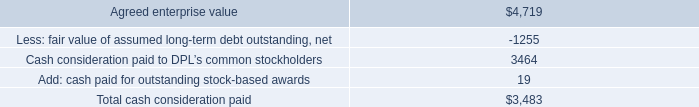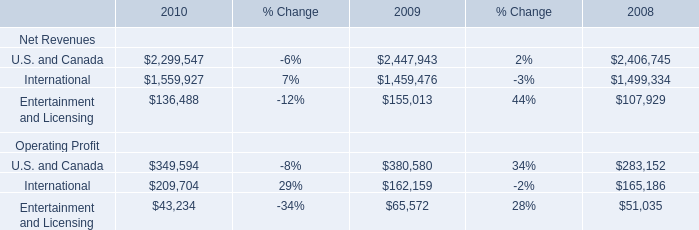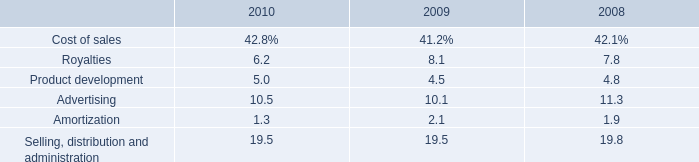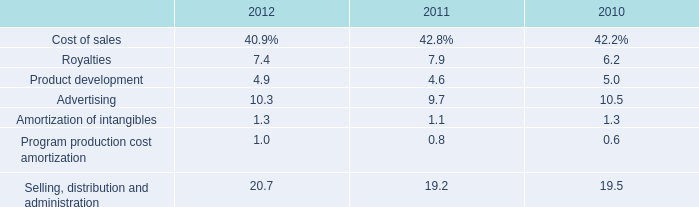What is the sum of Cash consideration paid to DPL’s common stockholders, and International Operating Profit of 2010 ? 
Computations: (3464.0 + 209704.0)
Answer: 213168.0. 